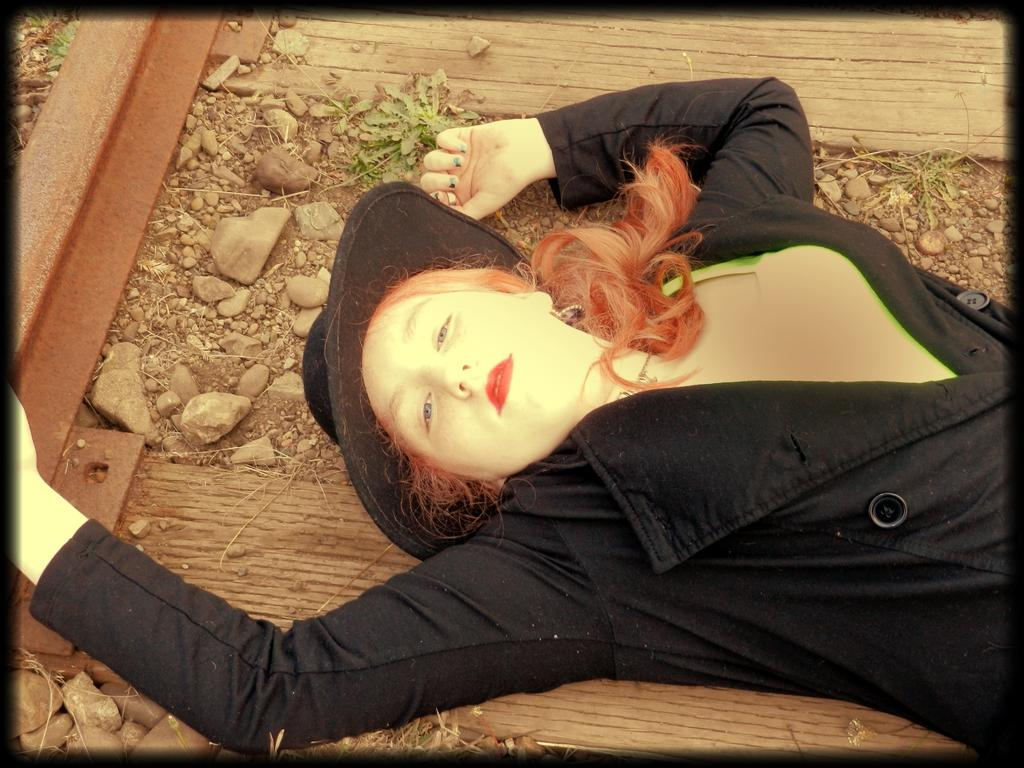Who is present in the image? There is a woman in the image. What type of object can be seen in the image? There is a metal object in the image. What material is used for the planks in the image? There are wooden planks in the image. What type of natural elements are present in the image? Leaves are present in the image. What is visible on the ground in the image? Stones are visible on the ground in the image. What type of glue is being used to hold the stones together in the image? There is no glue present in the image, and the stones are not being held together. 